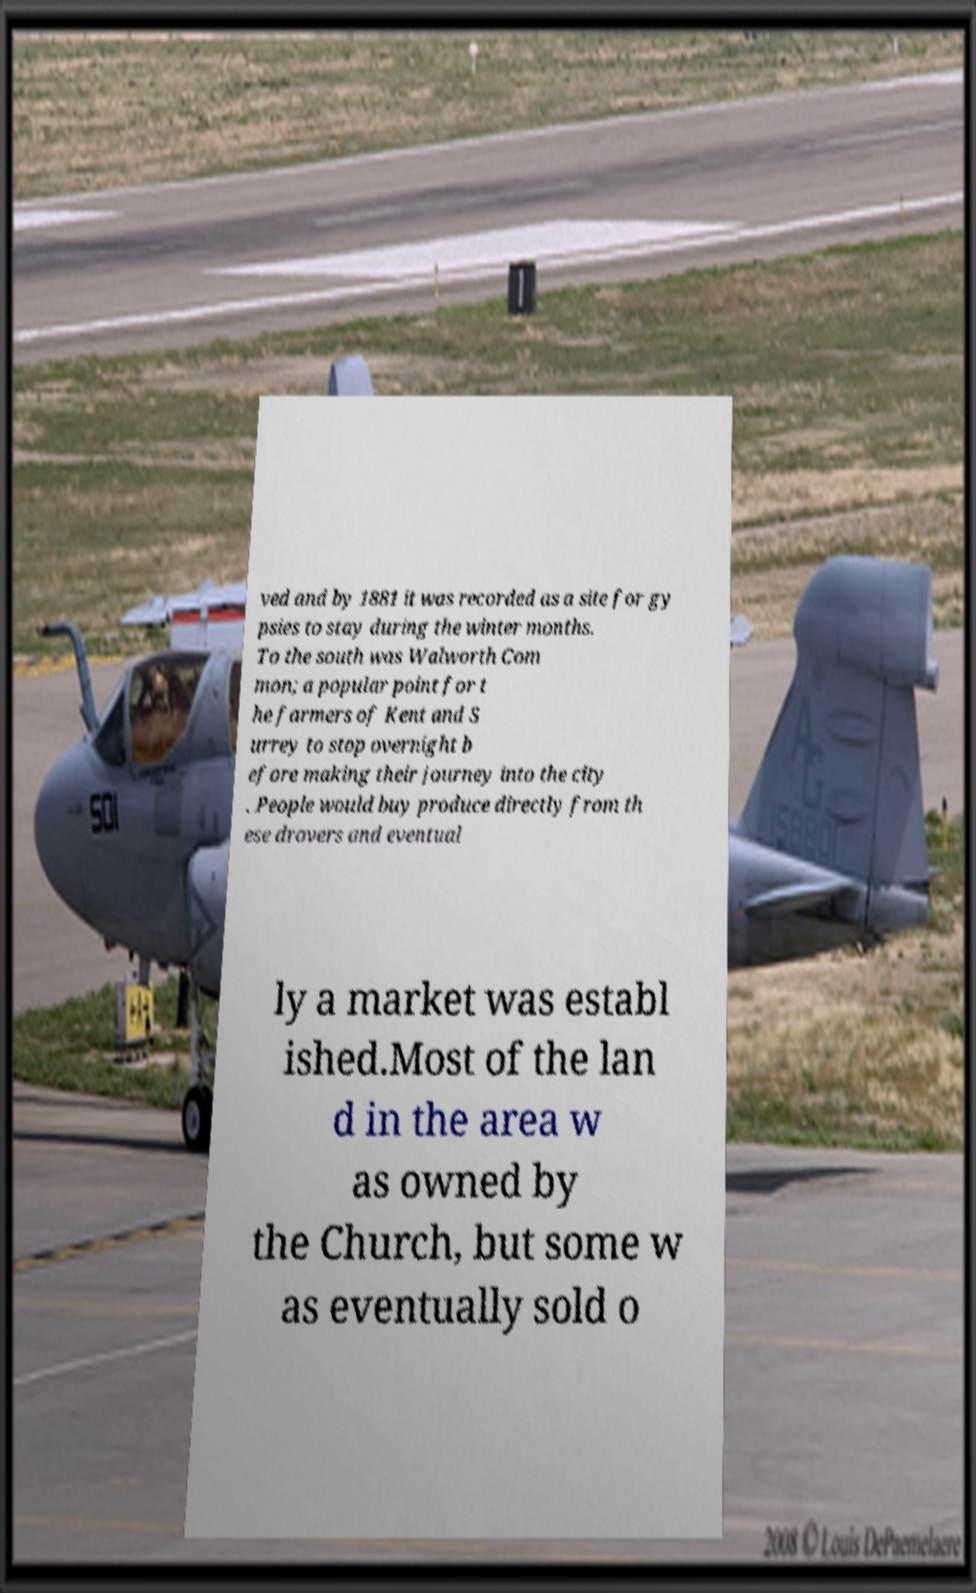Please identify and transcribe the text found in this image. ved and by 1881 it was recorded as a site for gy psies to stay during the winter months. To the south was Walworth Com mon; a popular point for t he farmers of Kent and S urrey to stop overnight b efore making their journey into the city . People would buy produce directly from th ese drovers and eventual ly a market was establ ished.Most of the lan d in the area w as owned by the Church, but some w as eventually sold o 